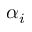<formula> <loc_0><loc_0><loc_500><loc_500>\alpha _ { i }</formula> 